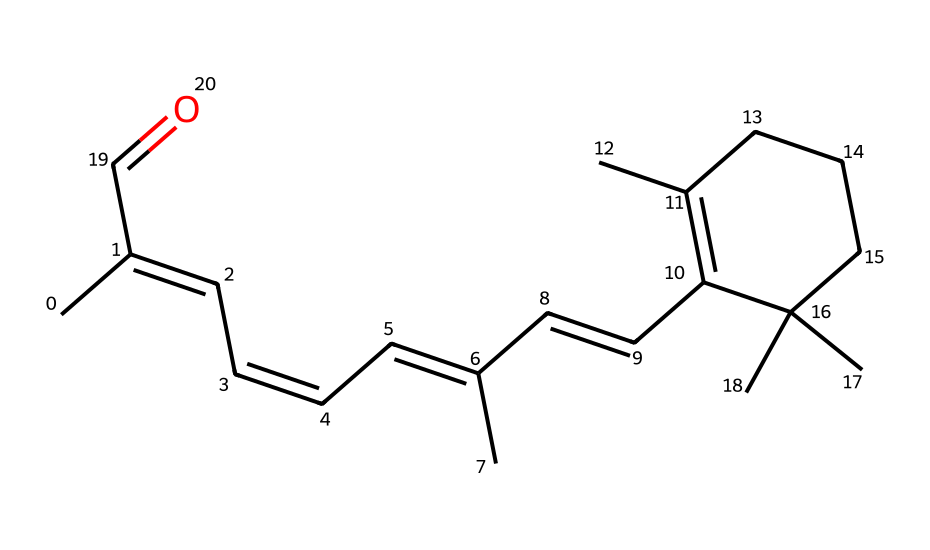What is the molecular weight of retinal? To find the molecular weight, we need to analyze the structure based on the provided SMILES. The molecular formula derived from the SMILES is C20H28O. The molecular weight is calculated by summing the atomic weights of all atoms: (20 * 12.01) + (28 * 1.008) + (1 * 16.00) = 284.42 g/mol.
Answer: 284.42 g/mol How many double bonds are present in retinal? The chemical structure shows multiple carbon-carbon double bonds (C=C). By examining the SMILES, it can be identified that there are six double bonds in total. Each double bond adds to the unique geometric isomerism properties of the molecule.
Answer: six Which functional group is present in retinal? In the provided SMILES, there's a carbonyl group (C=O) visible towards the end of the chain. This indicates the presence of an aldehyde functional group since it is located at the terminal carbon.
Answer: aldehyde What type of isomerism does retinal exhibit? Retinal can exist in different geometric forms owing to the presence of several double bonds, which allows for cis-trans isomerism across these bonds. This is fundamental to its function in vision as rhodopsin.
Answer: geometric isomerism Does retinal have cis or trans configurations? The presence of alternating double bonds in the SMILES indicates that retinal primarily exists in a trans configuration. This is crucial for its biological activity related to vision, specifically in its role within rhodopsin in the human eye.
Answer: trans What is the primary biological role of retinal? Retinal serves as a vital chromophore in the visual phototransduction pathway, where it undergoes isomerization upon light exposure, facilitating the conversion of light signals into visual signals in the retina.
Answer: vision 